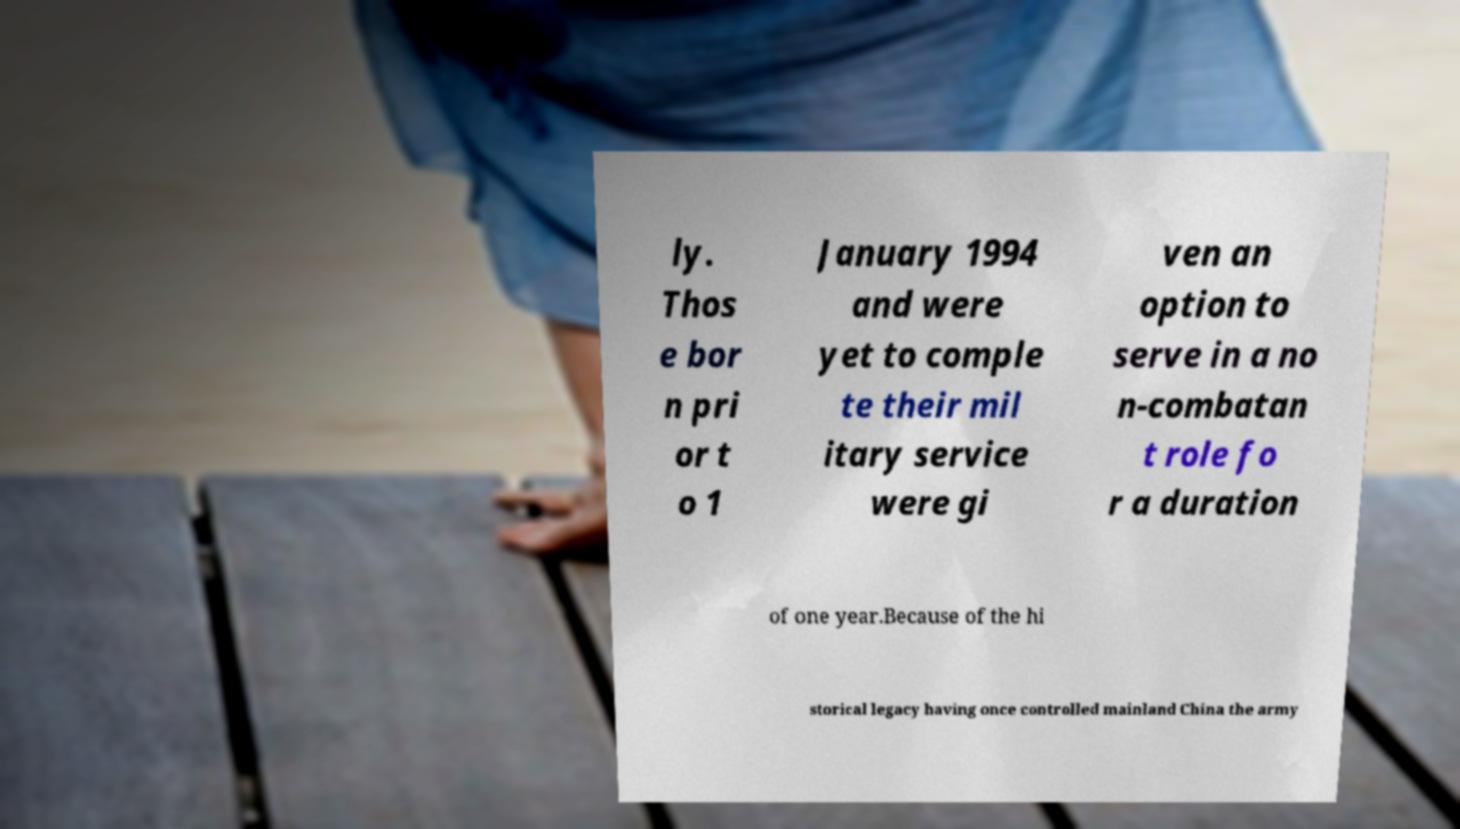I need the written content from this picture converted into text. Can you do that? ly. Thos e bor n pri or t o 1 January 1994 and were yet to comple te their mil itary service were gi ven an option to serve in a no n-combatan t role fo r a duration of one year.Because of the hi storical legacy having once controlled mainland China the army 